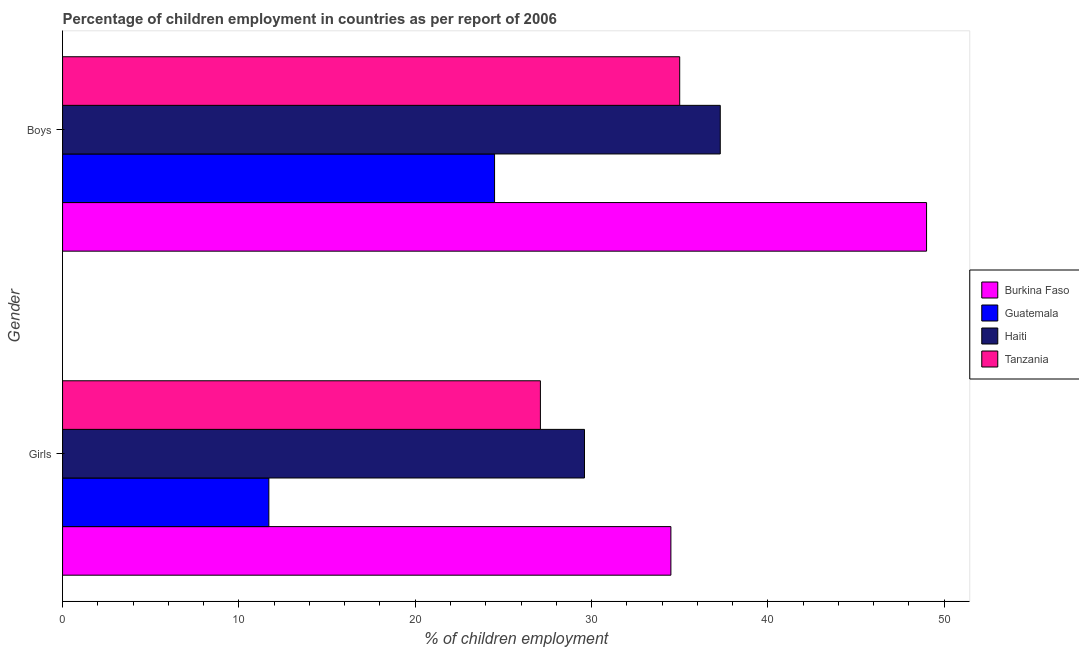How many different coloured bars are there?
Offer a very short reply. 4. How many groups of bars are there?
Your answer should be very brief. 2. Are the number of bars per tick equal to the number of legend labels?
Provide a short and direct response. Yes. Are the number of bars on each tick of the Y-axis equal?
Keep it short and to the point. Yes. What is the label of the 2nd group of bars from the top?
Provide a short and direct response. Girls. Across all countries, what is the minimum percentage of employed boys?
Ensure brevity in your answer.  24.5. In which country was the percentage of employed boys maximum?
Ensure brevity in your answer.  Burkina Faso. In which country was the percentage of employed boys minimum?
Provide a short and direct response. Guatemala. What is the total percentage of employed girls in the graph?
Make the answer very short. 102.9. What is the difference between the percentage of employed girls in Burkina Faso and that in Tanzania?
Make the answer very short. 7.4. What is the difference between the percentage of employed boys in Haiti and the percentage of employed girls in Guatemala?
Your response must be concise. 25.6. What is the average percentage of employed girls per country?
Give a very brief answer. 25.73. What is the difference between the percentage of employed boys and percentage of employed girls in Tanzania?
Provide a short and direct response. 7.9. What is the ratio of the percentage of employed girls in Guatemala to that in Burkina Faso?
Your answer should be very brief. 0.34. Is the percentage of employed girls in Haiti less than that in Tanzania?
Offer a terse response. No. In how many countries, is the percentage of employed girls greater than the average percentage of employed girls taken over all countries?
Provide a short and direct response. 3. What does the 3rd bar from the top in Boys represents?
Provide a succinct answer. Guatemala. What does the 4th bar from the bottom in Boys represents?
Ensure brevity in your answer.  Tanzania. How many bars are there?
Offer a terse response. 8. How many countries are there in the graph?
Your answer should be very brief. 4. What is the difference between two consecutive major ticks on the X-axis?
Your response must be concise. 10. Are the values on the major ticks of X-axis written in scientific E-notation?
Offer a terse response. No. Does the graph contain any zero values?
Give a very brief answer. No. Does the graph contain grids?
Your answer should be compact. No. Where does the legend appear in the graph?
Ensure brevity in your answer.  Center right. How many legend labels are there?
Give a very brief answer. 4. What is the title of the graph?
Make the answer very short. Percentage of children employment in countries as per report of 2006. What is the label or title of the X-axis?
Your answer should be very brief. % of children employment. What is the % of children employment of Burkina Faso in Girls?
Give a very brief answer. 34.5. What is the % of children employment in Guatemala in Girls?
Give a very brief answer. 11.7. What is the % of children employment of Haiti in Girls?
Your response must be concise. 29.6. What is the % of children employment of Tanzania in Girls?
Provide a succinct answer. 27.1. What is the % of children employment in Burkina Faso in Boys?
Give a very brief answer. 49. What is the % of children employment of Guatemala in Boys?
Ensure brevity in your answer.  24.5. What is the % of children employment of Haiti in Boys?
Provide a short and direct response. 37.3. Across all Gender, what is the maximum % of children employment of Burkina Faso?
Keep it short and to the point. 49. Across all Gender, what is the maximum % of children employment in Haiti?
Provide a succinct answer. 37.3. Across all Gender, what is the maximum % of children employment of Tanzania?
Offer a terse response. 35. Across all Gender, what is the minimum % of children employment of Burkina Faso?
Give a very brief answer. 34.5. Across all Gender, what is the minimum % of children employment of Guatemala?
Ensure brevity in your answer.  11.7. Across all Gender, what is the minimum % of children employment in Haiti?
Keep it short and to the point. 29.6. Across all Gender, what is the minimum % of children employment in Tanzania?
Make the answer very short. 27.1. What is the total % of children employment in Burkina Faso in the graph?
Your answer should be compact. 83.5. What is the total % of children employment in Guatemala in the graph?
Your answer should be compact. 36.2. What is the total % of children employment of Haiti in the graph?
Provide a succinct answer. 66.9. What is the total % of children employment of Tanzania in the graph?
Ensure brevity in your answer.  62.1. What is the difference between the % of children employment of Guatemala in Girls and that in Boys?
Provide a short and direct response. -12.8. What is the difference between the % of children employment of Tanzania in Girls and that in Boys?
Your answer should be very brief. -7.9. What is the difference between the % of children employment of Burkina Faso in Girls and the % of children employment of Guatemala in Boys?
Keep it short and to the point. 10. What is the difference between the % of children employment of Guatemala in Girls and the % of children employment of Haiti in Boys?
Ensure brevity in your answer.  -25.6. What is the difference between the % of children employment of Guatemala in Girls and the % of children employment of Tanzania in Boys?
Make the answer very short. -23.3. What is the average % of children employment in Burkina Faso per Gender?
Your answer should be very brief. 41.75. What is the average % of children employment of Guatemala per Gender?
Your answer should be compact. 18.1. What is the average % of children employment in Haiti per Gender?
Keep it short and to the point. 33.45. What is the average % of children employment of Tanzania per Gender?
Give a very brief answer. 31.05. What is the difference between the % of children employment in Burkina Faso and % of children employment in Guatemala in Girls?
Your answer should be very brief. 22.8. What is the difference between the % of children employment of Burkina Faso and % of children employment of Haiti in Girls?
Your response must be concise. 4.9. What is the difference between the % of children employment in Guatemala and % of children employment in Haiti in Girls?
Offer a very short reply. -17.9. What is the difference between the % of children employment in Guatemala and % of children employment in Tanzania in Girls?
Your answer should be very brief. -15.4. What is the difference between the % of children employment of Haiti and % of children employment of Tanzania in Girls?
Make the answer very short. 2.5. What is the difference between the % of children employment of Burkina Faso and % of children employment of Guatemala in Boys?
Ensure brevity in your answer.  24.5. What is the difference between the % of children employment in Burkina Faso and % of children employment in Haiti in Boys?
Offer a very short reply. 11.7. What is the difference between the % of children employment of Burkina Faso and % of children employment of Tanzania in Boys?
Offer a very short reply. 14. What is the difference between the % of children employment of Guatemala and % of children employment of Haiti in Boys?
Your response must be concise. -12.8. What is the difference between the % of children employment in Guatemala and % of children employment in Tanzania in Boys?
Provide a succinct answer. -10.5. What is the difference between the % of children employment of Haiti and % of children employment of Tanzania in Boys?
Keep it short and to the point. 2.3. What is the ratio of the % of children employment of Burkina Faso in Girls to that in Boys?
Make the answer very short. 0.7. What is the ratio of the % of children employment in Guatemala in Girls to that in Boys?
Your answer should be very brief. 0.48. What is the ratio of the % of children employment in Haiti in Girls to that in Boys?
Provide a succinct answer. 0.79. What is the ratio of the % of children employment of Tanzania in Girls to that in Boys?
Give a very brief answer. 0.77. What is the difference between the highest and the second highest % of children employment in Burkina Faso?
Provide a short and direct response. 14.5. What is the difference between the highest and the second highest % of children employment in Tanzania?
Provide a succinct answer. 7.9. What is the difference between the highest and the lowest % of children employment in Guatemala?
Provide a short and direct response. 12.8. What is the difference between the highest and the lowest % of children employment in Haiti?
Offer a terse response. 7.7. What is the difference between the highest and the lowest % of children employment of Tanzania?
Your answer should be very brief. 7.9. 